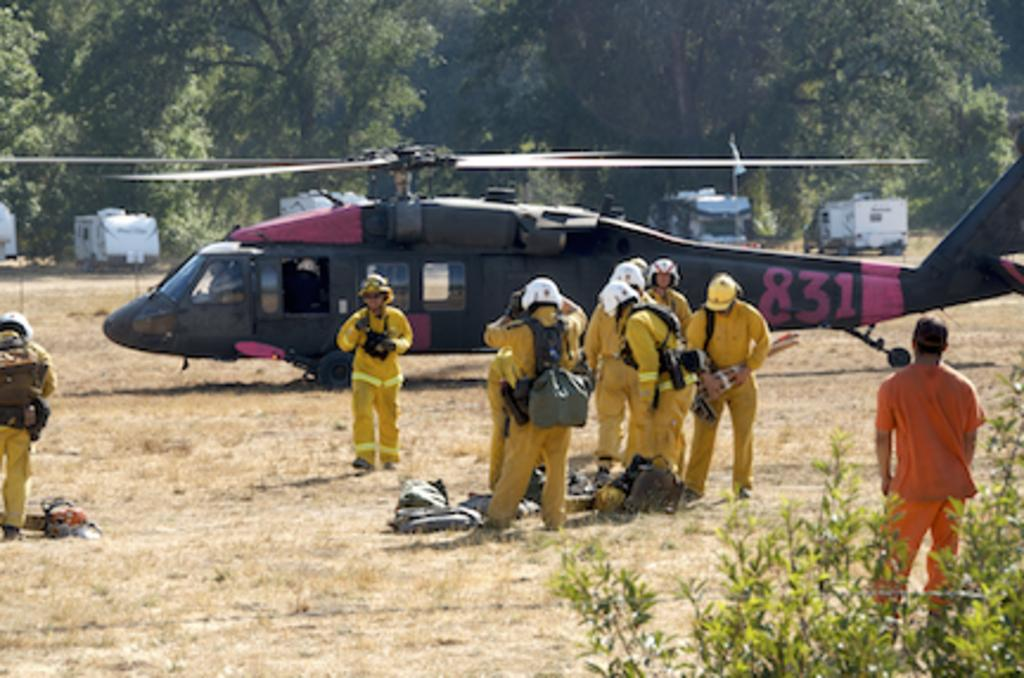<image>
Describe the image concisely. Several people in yellow suits stand outside a 831 Helicopter. 